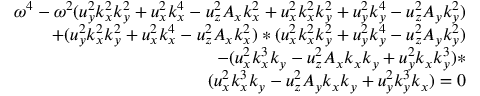<formula> <loc_0><loc_0><loc_500><loc_500>\begin{array} { r } { \omega ^ { 4 } - \omega ^ { 2 } ( u _ { y } ^ { 2 } k _ { x } ^ { 2 } k _ { y } ^ { 2 } + u _ { x } ^ { 2 } k _ { x } ^ { 4 } - u _ { z } ^ { 2 } A _ { x } k _ { x } ^ { 2 } + u _ { x } ^ { 2 } k _ { x } ^ { 2 } k _ { y } ^ { 2 } + u _ { y } ^ { 2 } k _ { y } ^ { 4 } - u _ { z } ^ { 2 } A _ { y } k _ { y } ^ { 2 } ) } \\ { + ( u _ { y } ^ { 2 } k _ { x } ^ { 2 } k _ { y } ^ { 2 } + u _ { x } ^ { 2 } k _ { x } ^ { 4 } - u _ { z } ^ { 2 } A _ { x } k _ { x } ^ { 2 } ) * ( u _ { x } ^ { 2 } k _ { x } ^ { 2 } k _ { y } ^ { 2 } + u _ { y } ^ { 2 } k _ { y } ^ { 4 } - u _ { z } ^ { 2 } A _ { y } k _ { y } ^ { 2 } ) } \\ { - ( u _ { x } ^ { 2 } k _ { x } ^ { 3 } k _ { y } - u _ { z } ^ { 2 } A _ { x } k _ { x } k _ { y } + u _ { y } ^ { 2 } k _ { x } k _ { y } ^ { 3 } ) * } \\ { ( u _ { x } ^ { 2 } k _ { x } ^ { 3 } k _ { y } - u _ { z } ^ { 2 } A _ { y } k _ { x } k _ { y } + u _ { y } ^ { 2 } k _ { y } ^ { 3 } k _ { x } ) = 0 } \end{array}</formula> 